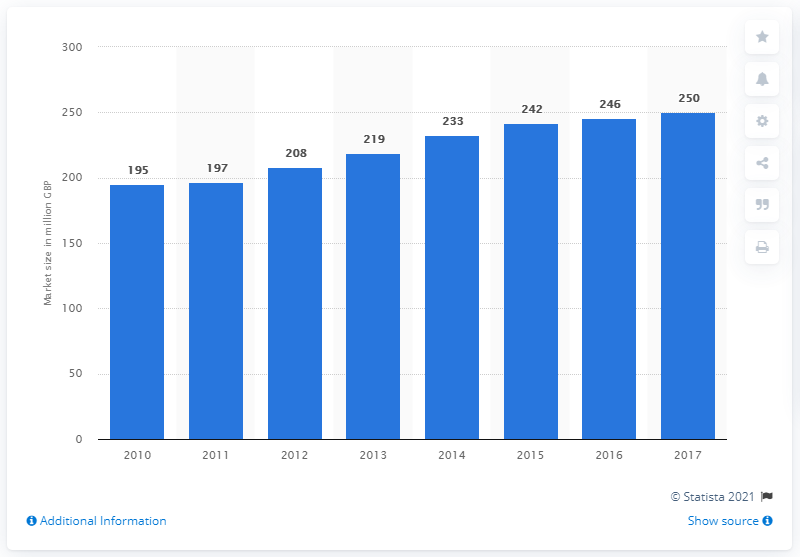Indicate a few pertinent items in this graphic. In 2010, the cyber security defense and intelligence segment was forecasted to grow significantly in the UK. The defense and security subsector is estimated to have been roughly 250 in size in 2017. 